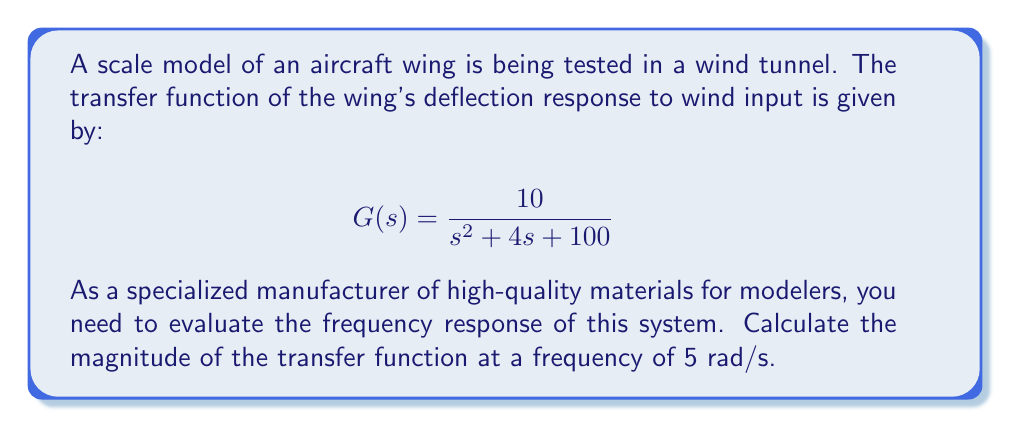Solve this math problem. To evaluate the frequency response, we need to follow these steps:

1) Replace $s$ with $j\omega$ in the transfer function, where $\omega = 5$ rad/s:

   $$G(j\omega) = \frac{10}{(j\omega)^2 + 4(j\omega) + 100}$$

2) Substitute $\omega = 5$:

   $$G(j5) = \frac{10}{(j5)^2 + 4(j5) + 100}$$

3) Simplify:

   $$G(j5) = \frac{10}{-25 + 20j + 100} = \frac{10}{75 + 20j}$$

4) To find the magnitude, we use the formula $|G(j\omega)| = \sqrt{Re^2 + Im^2}$:

   $$|G(j5)| = \left|\frac{10}{75 + 20j}\right| = \frac{10}{\sqrt{75^2 + 20^2}}$$

5) Calculate:

   $$|G(j5)| = \frac{10}{\sqrt{5625 + 400}} = \frac{10}{\sqrt{6025}} = \frac{10}{77.62} \approx 0.1288$$

Thus, the magnitude of the transfer function at a frequency of 5 rad/s is approximately 0.1288.
Answer: $|G(j5)| \approx 0.1288$ 